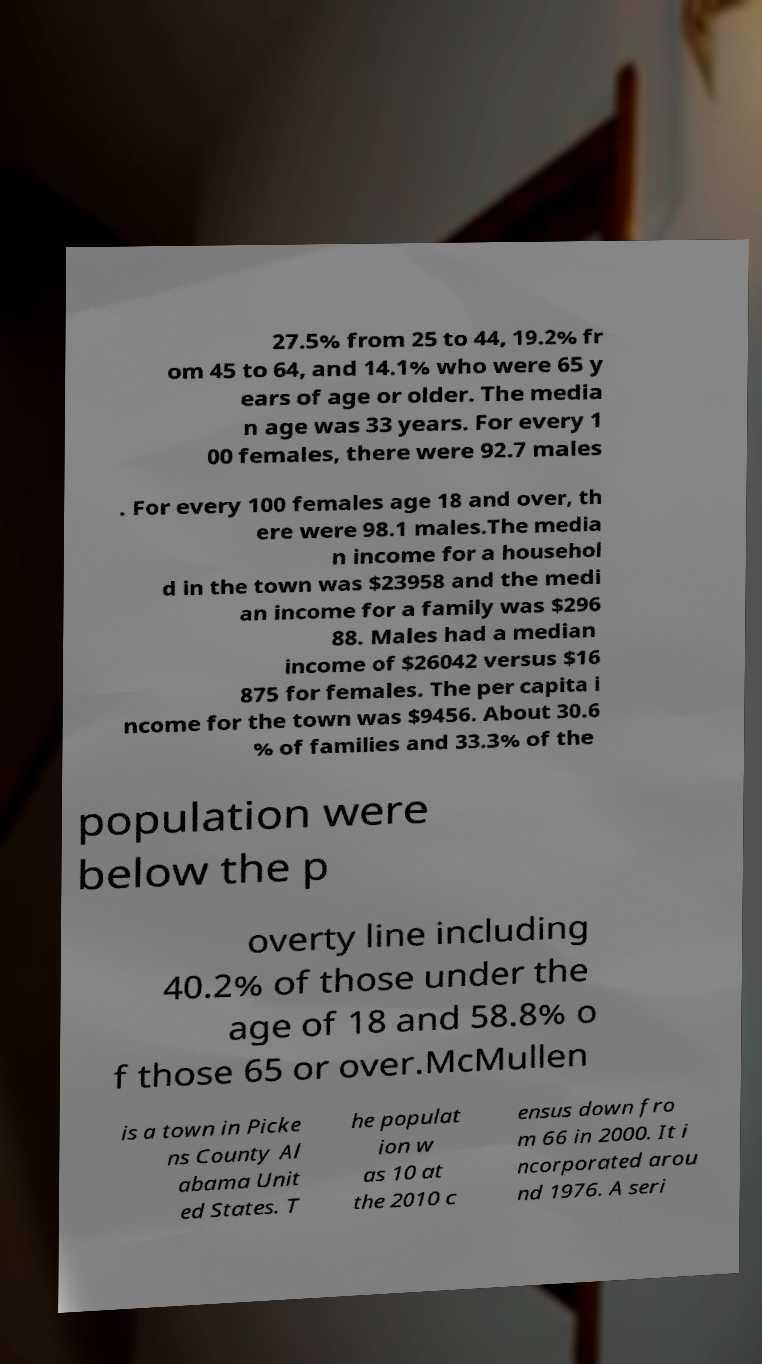What messages or text are displayed in this image? I need them in a readable, typed format. 27.5% from 25 to 44, 19.2% fr om 45 to 64, and 14.1% who were 65 y ears of age or older. The media n age was 33 years. For every 1 00 females, there were 92.7 males . For every 100 females age 18 and over, th ere were 98.1 males.The media n income for a househol d in the town was $23958 and the medi an income for a family was $296 88. Males had a median income of $26042 versus $16 875 for females. The per capita i ncome for the town was $9456. About 30.6 % of families and 33.3% of the population were below the p overty line including 40.2% of those under the age of 18 and 58.8% o f those 65 or over.McMullen is a town in Picke ns County Al abama Unit ed States. T he populat ion w as 10 at the 2010 c ensus down fro m 66 in 2000. It i ncorporated arou nd 1976. A seri 